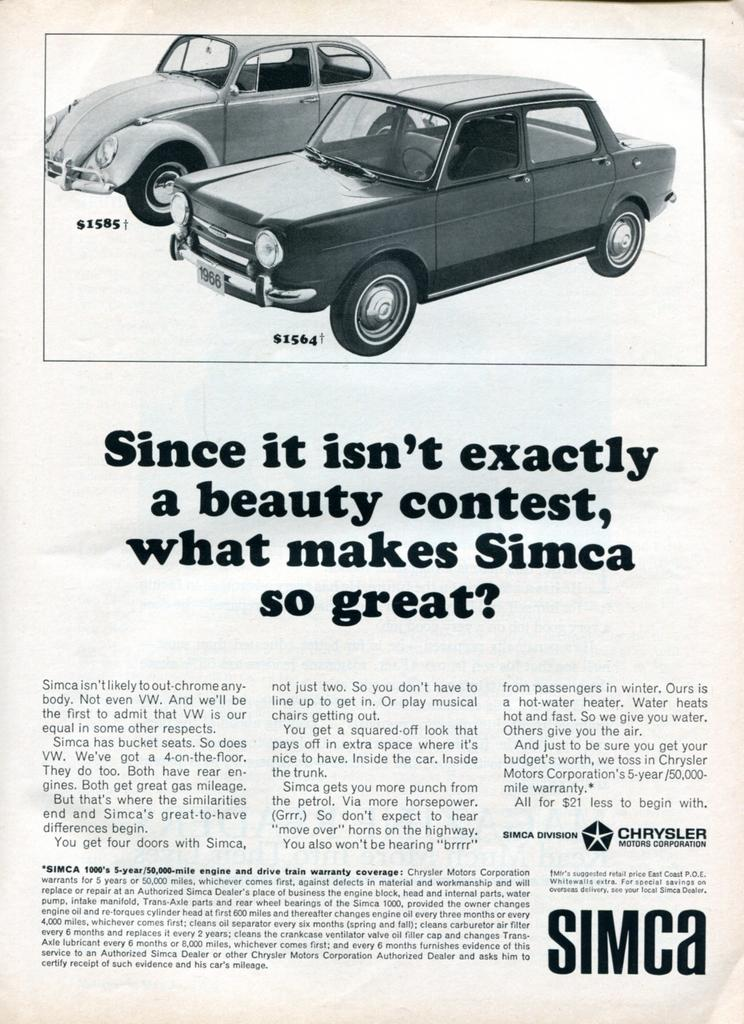What is featured in the image? There is a poster in the image. What is depicted in the picture on the poster? The picture on the poster contains a picture of cars. What else can be found on the poster besides the image? There is text on the poster. How many horses are visible in the image? There are no horses present in the image; it features a poster with a picture of cars and text. 